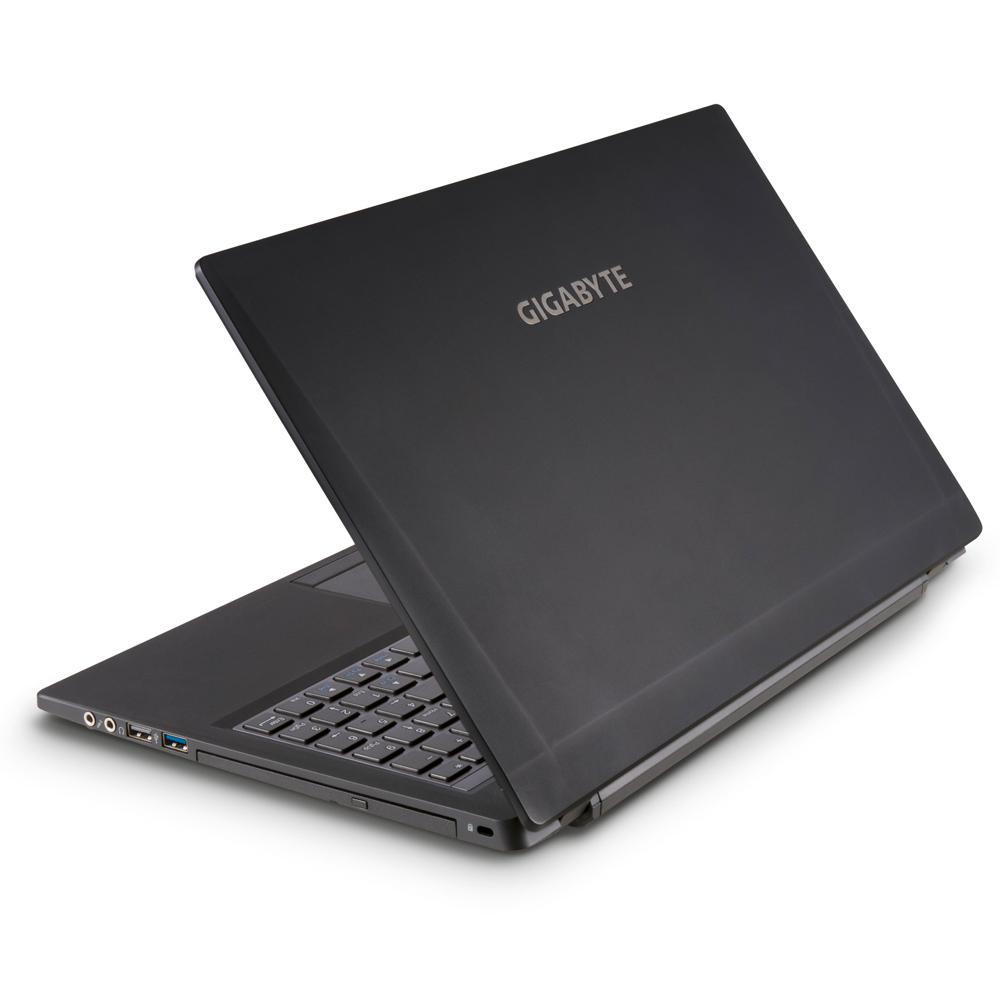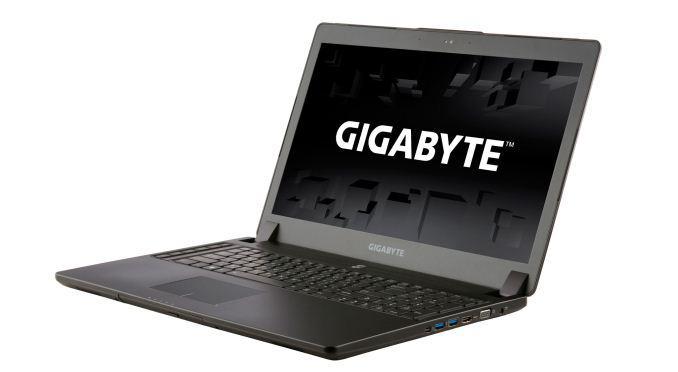The first image is the image on the left, the second image is the image on the right. Evaluate the accuracy of this statement regarding the images: "The left and right image contains the same number of laptops with one half opened and the other fully opened.". Is it true? Answer yes or no. Yes. The first image is the image on the left, the second image is the image on the right. Analyze the images presented: Is the assertion "Each image contains a single laptop, and one image features a laptop with the screen open to at least a right angle and visible, and the other image shows a laptop facing backward and open at less than 90-degrees." valid? Answer yes or no. Yes. 